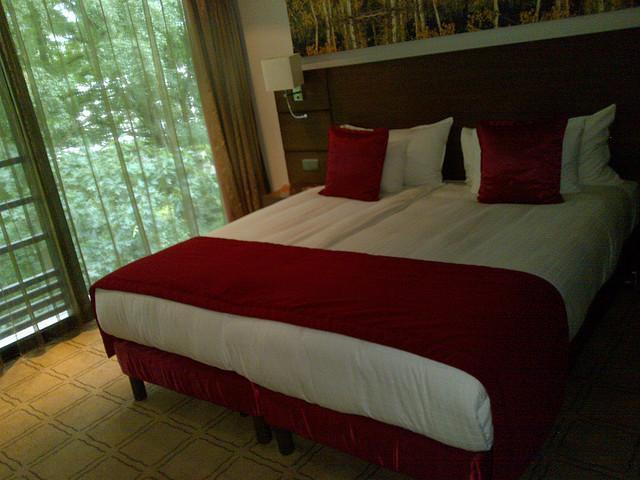How many pillows are in this room?
Give a very brief answer. 6. How many people are wearing a gray jacket?
Give a very brief answer. 0. 